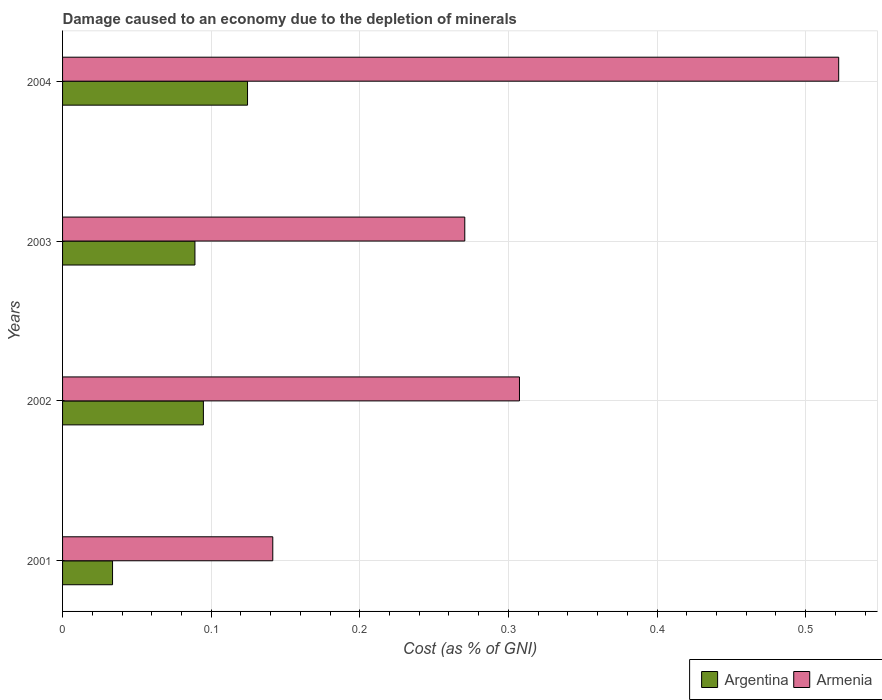How many different coloured bars are there?
Your answer should be compact. 2. How many bars are there on the 4th tick from the top?
Ensure brevity in your answer.  2. In how many cases, is the number of bars for a given year not equal to the number of legend labels?
Give a very brief answer. 0. What is the cost of damage caused due to the depletion of minerals in Argentina in 2004?
Ensure brevity in your answer.  0.12. Across all years, what is the maximum cost of damage caused due to the depletion of minerals in Argentina?
Make the answer very short. 0.12. Across all years, what is the minimum cost of damage caused due to the depletion of minerals in Argentina?
Ensure brevity in your answer.  0.03. In which year was the cost of damage caused due to the depletion of minerals in Armenia maximum?
Provide a short and direct response. 2004. What is the total cost of damage caused due to the depletion of minerals in Argentina in the graph?
Offer a very short reply. 0.34. What is the difference between the cost of damage caused due to the depletion of minerals in Argentina in 2002 and that in 2004?
Provide a succinct answer. -0.03. What is the difference between the cost of damage caused due to the depletion of minerals in Argentina in 2001 and the cost of damage caused due to the depletion of minerals in Armenia in 2002?
Provide a succinct answer. -0.27. What is the average cost of damage caused due to the depletion of minerals in Argentina per year?
Ensure brevity in your answer.  0.09. In the year 2001, what is the difference between the cost of damage caused due to the depletion of minerals in Armenia and cost of damage caused due to the depletion of minerals in Argentina?
Your answer should be compact. 0.11. In how many years, is the cost of damage caused due to the depletion of minerals in Argentina greater than 0.52 %?
Give a very brief answer. 0. What is the ratio of the cost of damage caused due to the depletion of minerals in Argentina in 2001 to that in 2004?
Your answer should be very brief. 0.27. What is the difference between the highest and the second highest cost of damage caused due to the depletion of minerals in Argentina?
Your answer should be very brief. 0.03. What is the difference between the highest and the lowest cost of damage caused due to the depletion of minerals in Argentina?
Offer a very short reply. 0.09. In how many years, is the cost of damage caused due to the depletion of minerals in Argentina greater than the average cost of damage caused due to the depletion of minerals in Argentina taken over all years?
Provide a succinct answer. 3. What does the 1st bar from the top in 2003 represents?
Make the answer very short. Armenia. Are all the bars in the graph horizontal?
Keep it short and to the point. Yes. How many years are there in the graph?
Make the answer very short. 4. What is the difference between two consecutive major ticks on the X-axis?
Provide a succinct answer. 0.1. Where does the legend appear in the graph?
Your answer should be compact. Bottom right. How many legend labels are there?
Provide a short and direct response. 2. How are the legend labels stacked?
Your answer should be very brief. Horizontal. What is the title of the graph?
Offer a very short reply. Damage caused to an economy due to the depletion of minerals. Does "Fragile and conflict affected situations" appear as one of the legend labels in the graph?
Keep it short and to the point. No. What is the label or title of the X-axis?
Your answer should be compact. Cost (as % of GNI). What is the label or title of the Y-axis?
Make the answer very short. Years. What is the Cost (as % of GNI) of Argentina in 2001?
Make the answer very short. 0.03. What is the Cost (as % of GNI) of Armenia in 2001?
Offer a terse response. 0.14. What is the Cost (as % of GNI) of Argentina in 2002?
Provide a succinct answer. 0.09. What is the Cost (as % of GNI) of Armenia in 2002?
Offer a very short reply. 0.31. What is the Cost (as % of GNI) in Argentina in 2003?
Provide a succinct answer. 0.09. What is the Cost (as % of GNI) in Armenia in 2003?
Give a very brief answer. 0.27. What is the Cost (as % of GNI) of Argentina in 2004?
Make the answer very short. 0.12. What is the Cost (as % of GNI) in Armenia in 2004?
Your answer should be compact. 0.52. Across all years, what is the maximum Cost (as % of GNI) in Argentina?
Provide a succinct answer. 0.12. Across all years, what is the maximum Cost (as % of GNI) of Armenia?
Your answer should be compact. 0.52. Across all years, what is the minimum Cost (as % of GNI) in Argentina?
Your answer should be very brief. 0.03. Across all years, what is the minimum Cost (as % of GNI) of Armenia?
Keep it short and to the point. 0.14. What is the total Cost (as % of GNI) in Argentina in the graph?
Your answer should be compact. 0.34. What is the total Cost (as % of GNI) of Armenia in the graph?
Ensure brevity in your answer.  1.24. What is the difference between the Cost (as % of GNI) in Argentina in 2001 and that in 2002?
Ensure brevity in your answer.  -0.06. What is the difference between the Cost (as % of GNI) in Armenia in 2001 and that in 2002?
Keep it short and to the point. -0.17. What is the difference between the Cost (as % of GNI) of Argentina in 2001 and that in 2003?
Keep it short and to the point. -0.06. What is the difference between the Cost (as % of GNI) of Armenia in 2001 and that in 2003?
Your answer should be very brief. -0.13. What is the difference between the Cost (as % of GNI) of Argentina in 2001 and that in 2004?
Your response must be concise. -0.09. What is the difference between the Cost (as % of GNI) of Armenia in 2001 and that in 2004?
Offer a terse response. -0.38. What is the difference between the Cost (as % of GNI) in Argentina in 2002 and that in 2003?
Keep it short and to the point. 0.01. What is the difference between the Cost (as % of GNI) of Armenia in 2002 and that in 2003?
Provide a short and direct response. 0.04. What is the difference between the Cost (as % of GNI) in Argentina in 2002 and that in 2004?
Provide a succinct answer. -0.03. What is the difference between the Cost (as % of GNI) of Armenia in 2002 and that in 2004?
Offer a terse response. -0.21. What is the difference between the Cost (as % of GNI) of Argentina in 2003 and that in 2004?
Make the answer very short. -0.04. What is the difference between the Cost (as % of GNI) in Armenia in 2003 and that in 2004?
Your answer should be compact. -0.25. What is the difference between the Cost (as % of GNI) in Argentina in 2001 and the Cost (as % of GNI) in Armenia in 2002?
Keep it short and to the point. -0.27. What is the difference between the Cost (as % of GNI) in Argentina in 2001 and the Cost (as % of GNI) in Armenia in 2003?
Ensure brevity in your answer.  -0.24. What is the difference between the Cost (as % of GNI) of Argentina in 2001 and the Cost (as % of GNI) of Armenia in 2004?
Provide a succinct answer. -0.49. What is the difference between the Cost (as % of GNI) of Argentina in 2002 and the Cost (as % of GNI) of Armenia in 2003?
Ensure brevity in your answer.  -0.18. What is the difference between the Cost (as % of GNI) in Argentina in 2002 and the Cost (as % of GNI) in Armenia in 2004?
Give a very brief answer. -0.43. What is the difference between the Cost (as % of GNI) of Argentina in 2003 and the Cost (as % of GNI) of Armenia in 2004?
Your answer should be very brief. -0.43. What is the average Cost (as % of GNI) of Argentina per year?
Your answer should be compact. 0.09. What is the average Cost (as % of GNI) in Armenia per year?
Give a very brief answer. 0.31. In the year 2001, what is the difference between the Cost (as % of GNI) of Argentina and Cost (as % of GNI) of Armenia?
Provide a succinct answer. -0.11. In the year 2002, what is the difference between the Cost (as % of GNI) in Argentina and Cost (as % of GNI) in Armenia?
Offer a terse response. -0.21. In the year 2003, what is the difference between the Cost (as % of GNI) of Argentina and Cost (as % of GNI) of Armenia?
Ensure brevity in your answer.  -0.18. In the year 2004, what is the difference between the Cost (as % of GNI) of Argentina and Cost (as % of GNI) of Armenia?
Make the answer very short. -0.4. What is the ratio of the Cost (as % of GNI) of Argentina in 2001 to that in 2002?
Give a very brief answer. 0.35. What is the ratio of the Cost (as % of GNI) in Armenia in 2001 to that in 2002?
Provide a short and direct response. 0.46. What is the ratio of the Cost (as % of GNI) in Argentina in 2001 to that in 2003?
Ensure brevity in your answer.  0.38. What is the ratio of the Cost (as % of GNI) of Armenia in 2001 to that in 2003?
Your answer should be very brief. 0.52. What is the ratio of the Cost (as % of GNI) in Argentina in 2001 to that in 2004?
Provide a short and direct response. 0.27. What is the ratio of the Cost (as % of GNI) in Armenia in 2001 to that in 2004?
Provide a short and direct response. 0.27. What is the ratio of the Cost (as % of GNI) in Argentina in 2002 to that in 2003?
Your response must be concise. 1.06. What is the ratio of the Cost (as % of GNI) in Armenia in 2002 to that in 2003?
Provide a short and direct response. 1.14. What is the ratio of the Cost (as % of GNI) of Argentina in 2002 to that in 2004?
Make the answer very short. 0.76. What is the ratio of the Cost (as % of GNI) of Armenia in 2002 to that in 2004?
Offer a very short reply. 0.59. What is the ratio of the Cost (as % of GNI) in Argentina in 2003 to that in 2004?
Ensure brevity in your answer.  0.72. What is the ratio of the Cost (as % of GNI) of Armenia in 2003 to that in 2004?
Offer a very short reply. 0.52. What is the difference between the highest and the second highest Cost (as % of GNI) of Argentina?
Ensure brevity in your answer.  0.03. What is the difference between the highest and the second highest Cost (as % of GNI) of Armenia?
Offer a terse response. 0.21. What is the difference between the highest and the lowest Cost (as % of GNI) of Argentina?
Give a very brief answer. 0.09. What is the difference between the highest and the lowest Cost (as % of GNI) of Armenia?
Your answer should be very brief. 0.38. 